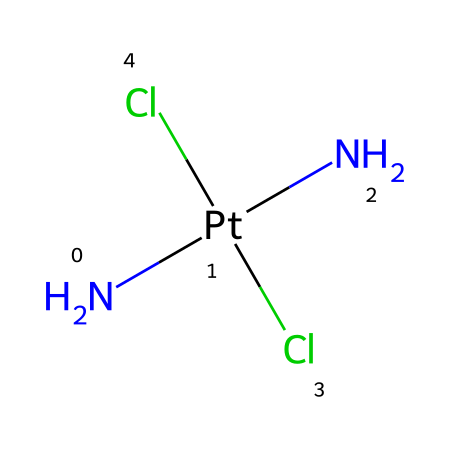What is the central metal atom in this coordination compound? The central metal atom is determined by identifying the element at the center of the coordination compound's structure. In the provided SMILES representation, '[Pt]' indicates that platinum is the central atom.
Answer: platinum How many chloride ligands are present in cisplatin? By examining the SMILES notation, we can count the number of chloride (Cl) ligands attached to the platinum atom. The notation specifies two Cl atoms.
Answer: 2 What is the oxidation state of the platinum atom in cisplatin? The oxidation state can be derived from the coordination environment. Platinum typically exhibits a +2 oxidation state in cisplatin due to the presence of two chloride ligands and two amine ligands, resulting in a neutral compound (0 overall charge).
Answer: +2 What is the coordination number of platinum in this compound? The coordination number is found by adding the number of ligands directly bonded to the central metal. In cisplatin, platinum is bonded to four ligands (two Cl and two NH3), thus the coordination number is 4.
Answer: 4 What is the molecular geometry of cisplatin? The molecular geometry is determined by the arrangement of the ligands around the central metal atom. With a coordination number of 4 and specific ligand types, cisplatin adopts a square planar geometry.
Answer: square planar Describe the type of isomerism exhibited by cisplatin. This coordination compound exhibits geometric isomerism, where the arrangement of ligands can vary, particularly in cis and trans forms. In the case of cisplatin, it has a specific arrangement that shows cis isomerism, with identical ligands adjacent to each other.
Answer: geometric isomerism 